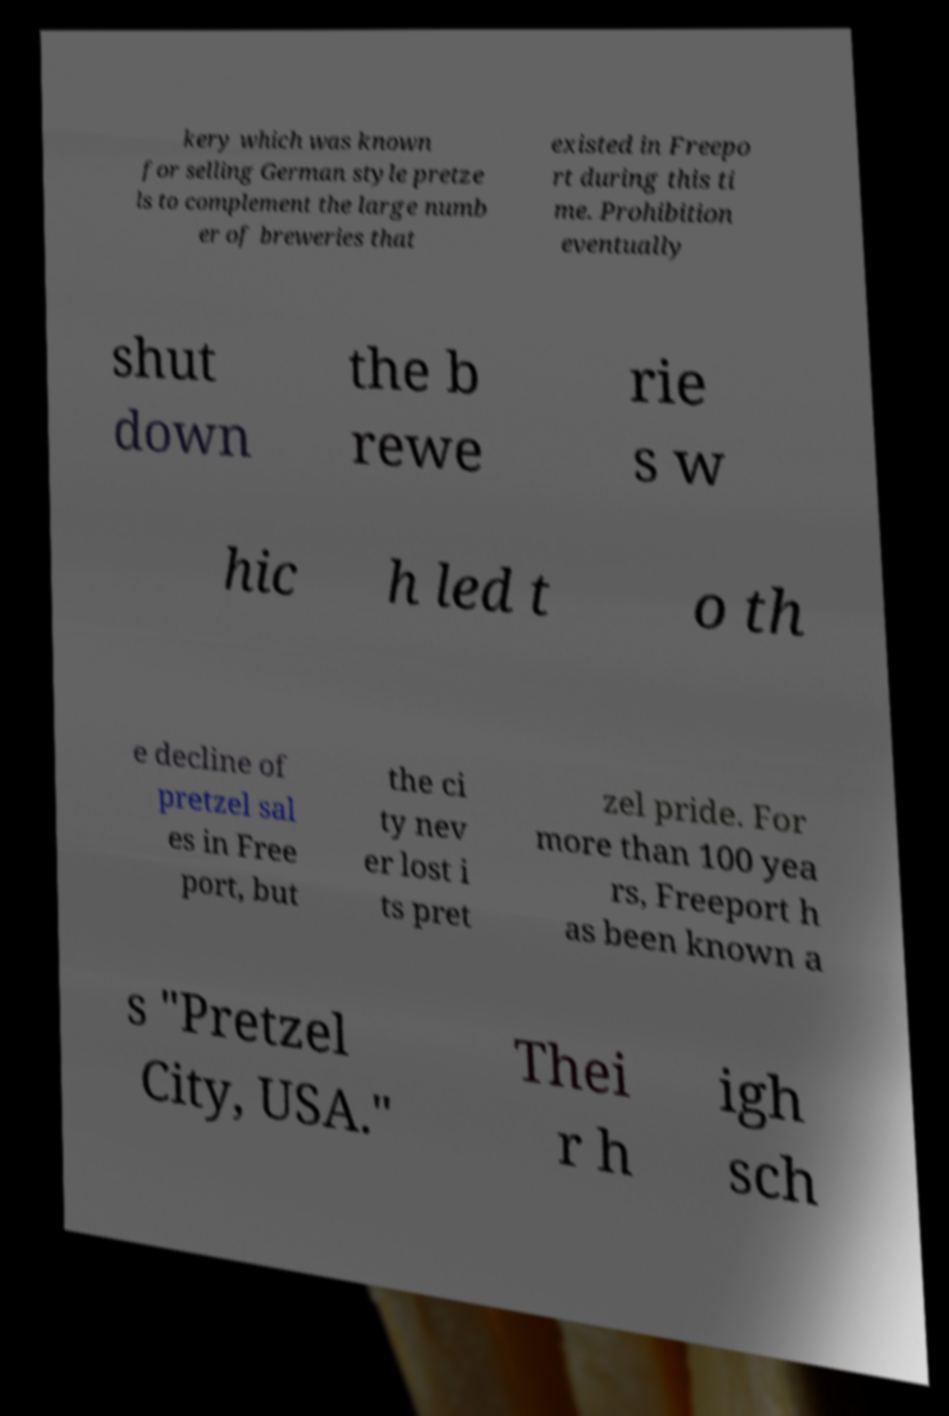Please identify and transcribe the text found in this image. kery which was known for selling German style pretze ls to complement the large numb er of breweries that existed in Freepo rt during this ti me. Prohibition eventually shut down the b rewe rie s w hic h led t o th e decline of pretzel sal es in Free port, but the ci ty nev er lost i ts pret zel pride. For more than 100 yea rs, Freeport h as been known a s "Pretzel City, USA." Thei r h igh sch 